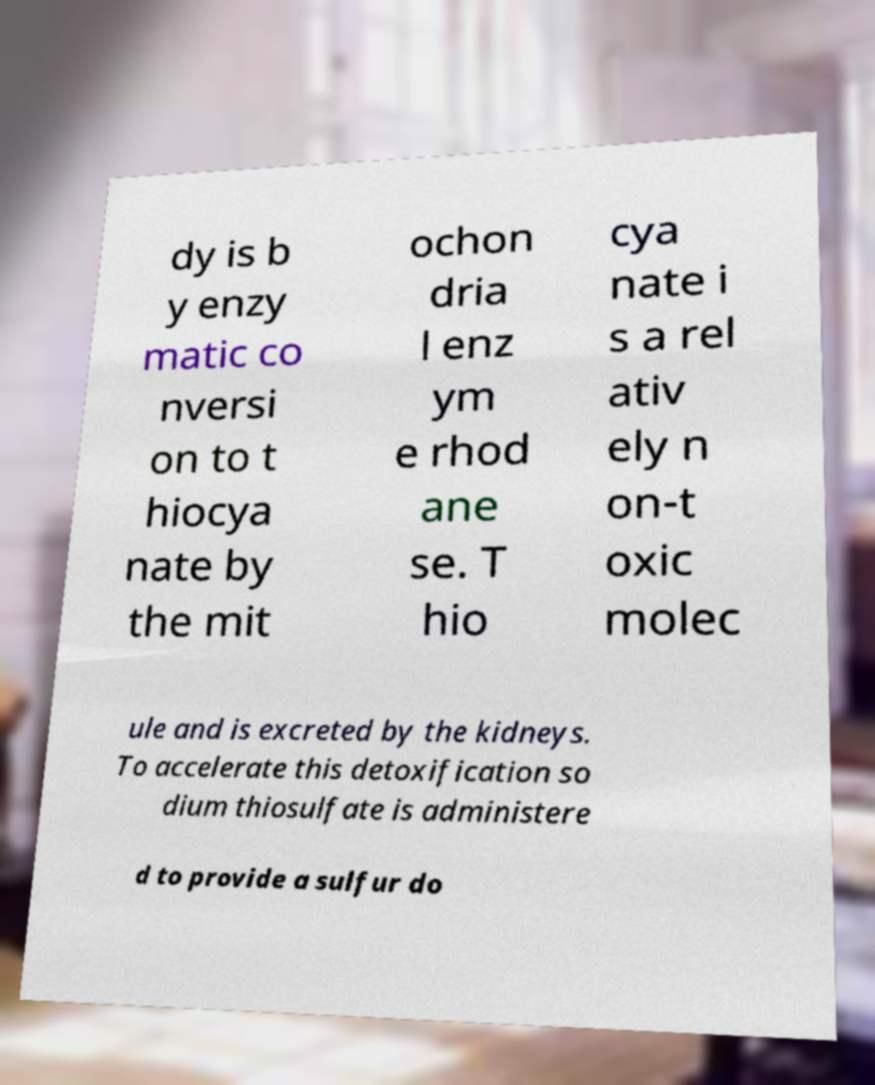Could you extract and type out the text from this image? dy is b y enzy matic co nversi on to t hiocya nate by the mit ochon dria l enz ym e rhod ane se. T hio cya nate i s a rel ativ ely n on-t oxic molec ule and is excreted by the kidneys. To accelerate this detoxification so dium thiosulfate is administere d to provide a sulfur do 